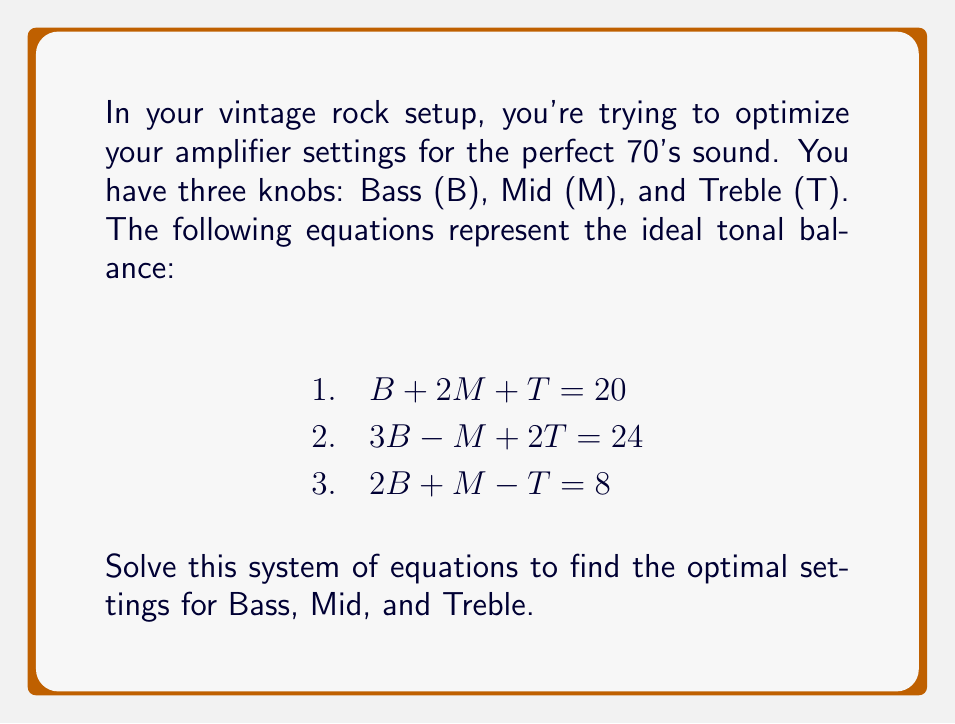Can you solve this math problem? Let's solve this system of equations using the elimination method:

Step 1: Multiply equation 1 by 3 and equation 2 by -1 to eliminate B:
$3(B + 2M + T = 20)$ gives: $3B + 6M + 3T = 60$ (Eq. 4)
$-1(3B - M + 2T = 24)$ gives: $-3B + M - 2T = -24$ (Eq. 5)

Adding Eq. 4 and Eq. 5:
$7M + T = 36$ (Eq. 6)

Step 2: Multiply equation 3 by 2:
$2(2B + M - T = 8)$ gives: $4B + 2M - 2T = 16$ (Eq. 7)

Step 3: Subtract Eq. 7 from Eq. 2:
$-B - 3M + 4T = 8$ (Eq. 8)

Step 4: Multiply Eq. 6 by 3 and Eq. 8 by 7:
$3(7M + T = 36)$ gives: $21M + 3T = 108$ (Eq. 9)
$7(-B - 3M + 4T = 8)$ gives: $-7B - 21M + 28T = 56$ (Eq. 10)

Adding Eq. 9 and Eq. 10:
$-7B + 31T = 164$

Step 5: Substitute this into Eq. 2:
$3B - M + 2(\frac{164+7B}{31}) = 24$
$3B - M + \frac{328+14B}{31} = 24$
$93B - 31M + 328 + 14B = 744$
$107B - 31M = 416$

Step 6: Use Eq. 1 to substitute for T in Eq. 3:
$2B + M - (20 - B - 2M) = 8$
$3B + 3M = 28$ (Eq. 11)

Step 7: Multiply Eq. 11 by 31 and subtract from the equation in Step 5:
$31(3B + 3M = 28)$ gives: $93B + 93M = 868$
$(107B - 31M = 416) - (93B + 93M = 868)$ gives:
$14B - 124M = -452$
$B - 8.857M = -32.286$ (Eq. 12)

Step 8: Substitute Eq. 12 into Eq. 11:
$3(-32.286 + 8.857M) + 3M = 28$
$-96.858 + 26.571M + 3M = 28$
$29.571M = 124.858$
$M = 4.222$

Step 9: Substitute M back into Eq. 12 to find B:
$B - 8.857(4.222) = -32.286$
$B - 37.394 = -32.286$
$B = 5.108$

Step 10: Use Eq. 1 to find T:
$5.108 + 2(4.222) + T = 20$
$5.108 + 8.444 + T = 20$
$T = 6.448$

Therefore, the optimal settings are:
Bass (B) ≈ 5.108
Mid (M) ≈ 4.222
Treble (T) ≈ 6.448
Answer: $B ≈ 5.108$, $M ≈ 4.222$, $T ≈ 6.448$ 